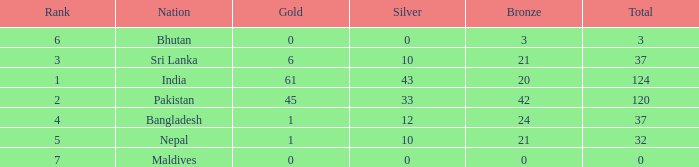Which Gold has a Rank smaller than 5, and a Bronze of 20? 61.0. 